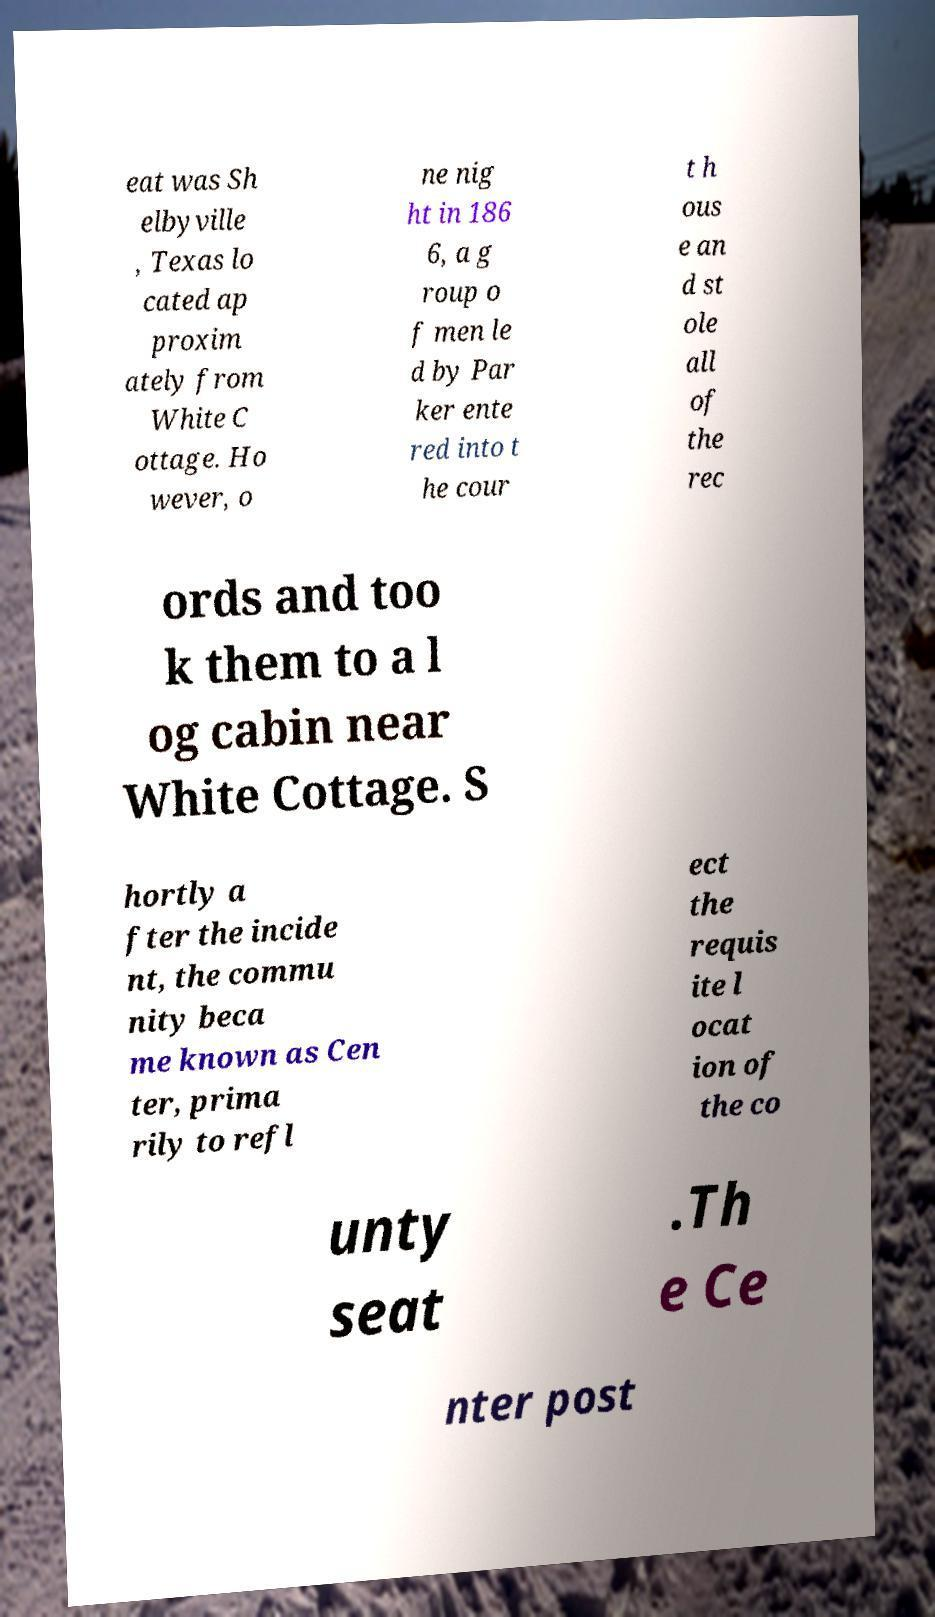Can you accurately transcribe the text from the provided image for me? eat was Sh elbyville , Texas lo cated ap proxim ately from White C ottage. Ho wever, o ne nig ht in 186 6, a g roup o f men le d by Par ker ente red into t he cour t h ous e an d st ole all of the rec ords and too k them to a l og cabin near White Cottage. S hortly a fter the incide nt, the commu nity beca me known as Cen ter, prima rily to refl ect the requis ite l ocat ion of the co unty seat .Th e Ce nter post 